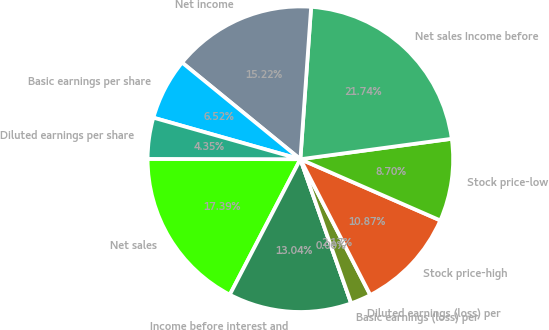Convert chart. <chart><loc_0><loc_0><loc_500><loc_500><pie_chart><fcel>Net sales<fcel>Income before interest and<fcel>Basic earnings (loss) per<fcel>Diluted earnings (loss) per<fcel>Stock price-high<fcel>Stock price-low<fcel>Net sales Income before<fcel>Net income<fcel>Basic earnings per share<fcel>Diluted earnings per share<nl><fcel>17.39%<fcel>13.04%<fcel>0.0%<fcel>2.17%<fcel>10.87%<fcel>8.7%<fcel>21.74%<fcel>15.22%<fcel>6.52%<fcel>4.35%<nl></chart> 